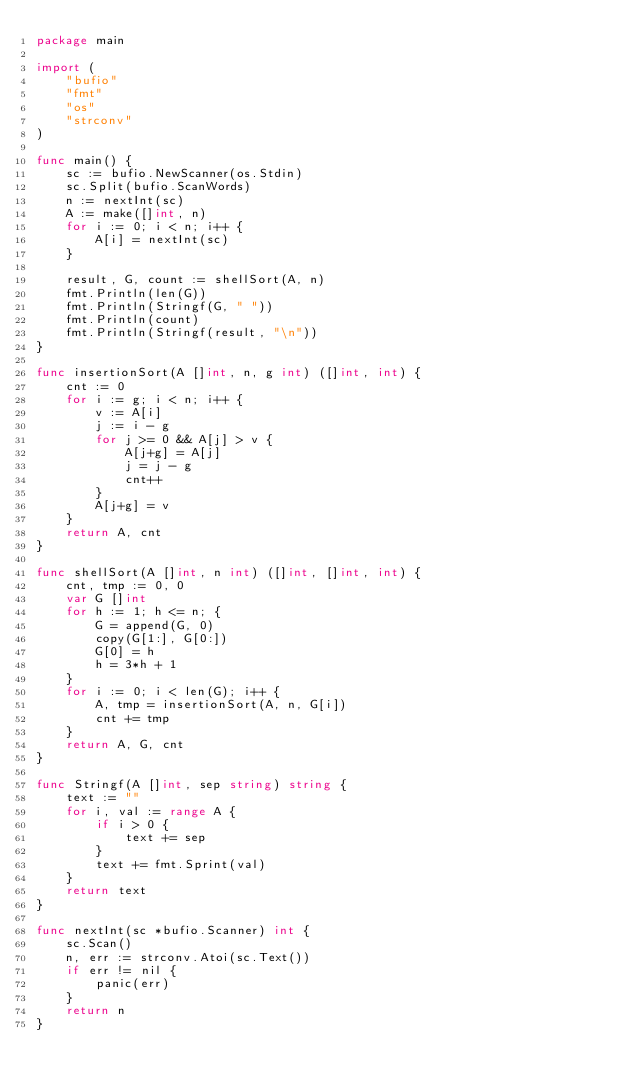Convert code to text. <code><loc_0><loc_0><loc_500><loc_500><_Go_>package main

import (
	"bufio"
	"fmt"
	"os"
	"strconv"
)

func main() {
	sc := bufio.NewScanner(os.Stdin)
	sc.Split(bufio.ScanWords)
	n := nextInt(sc)
	A := make([]int, n)
	for i := 0; i < n; i++ {
		A[i] = nextInt(sc)
	}

	result, G, count := shellSort(A, n)
	fmt.Println(len(G))
	fmt.Println(Stringf(G, " "))
	fmt.Println(count)
	fmt.Println(Stringf(result, "\n"))
}

func insertionSort(A []int, n, g int) ([]int, int) {
	cnt := 0
	for i := g; i < n; i++ {
		v := A[i]
		j := i - g
		for j >= 0 && A[j] > v {
			A[j+g] = A[j]
			j = j - g
			cnt++
		}
		A[j+g] = v
	}
	return A, cnt
}

func shellSort(A []int, n int) ([]int, []int, int) {
	cnt, tmp := 0, 0
	var G []int
	for h := 1; h <= n; {
		G = append(G, 0)
		copy(G[1:], G[0:])
		G[0] = h
		h = 3*h + 1
	}
	for i := 0; i < len(G); i++ {
		A, tmp = insertionSort(A, n, G[i])
		cnt += tmp
	}
	return A, G, cnt
}

func Stringf(A []int, sep string) string {
	text := ""
	for i, val := range A {
		if i > 0 {
			text += sep
		}
		text += fmt.Sprint(val)
	}
	return text
}

func nextInt(sc *bufio.Scanner) int {
	sc.Scan()
	n, err := strconv.Atoi(sc.Text())
	if err != nil {
		panic(err)
	}
	return n
}

</code> 